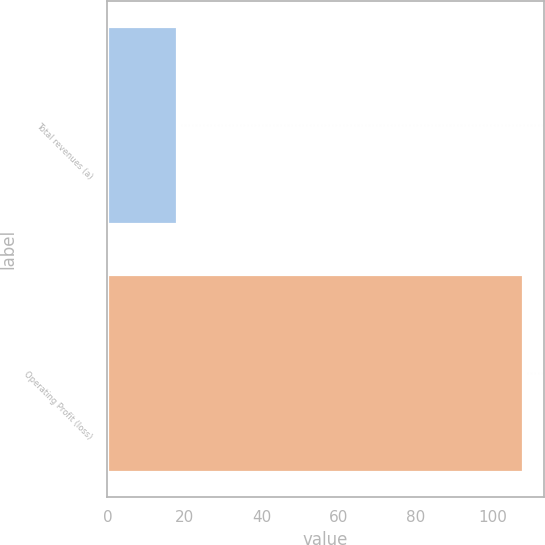Convert chart. <chart><loc_0><loc_0><loc_500><loc_500><bar_chart><fcel>Total revenues (a)<fcel>Operating Profit (loss)<nl><fcel>18<fcel>108<nl></chart> 